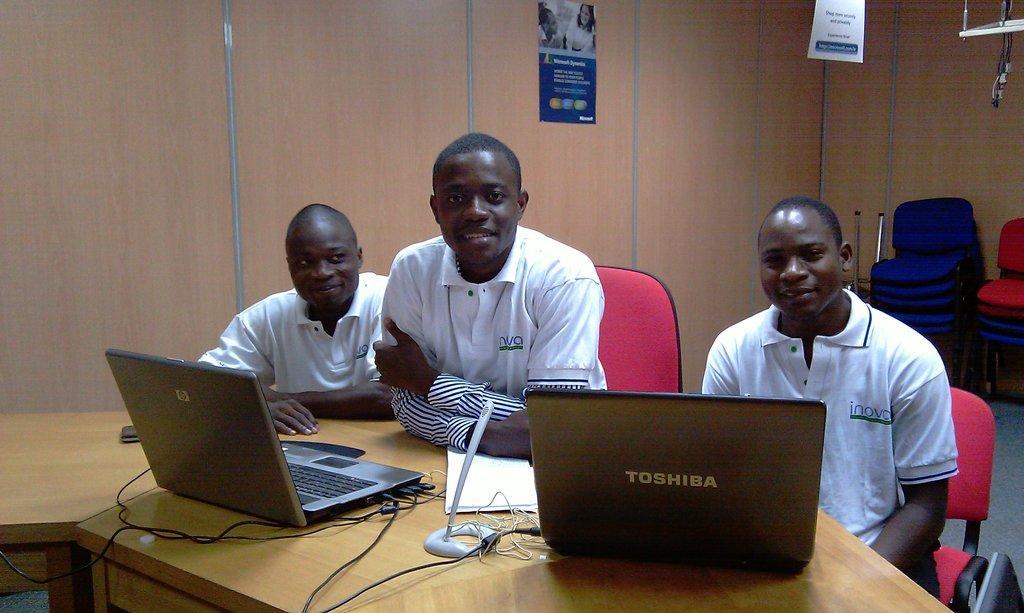Please provide a concise description of this image. There are three men sitting on a chair. They are wearing white t-shirts. In front of them there is a table. On the table there are two laptops, papers and wires. At the back of them there is a wall. On the wall there is a poster and there are some chairs. 